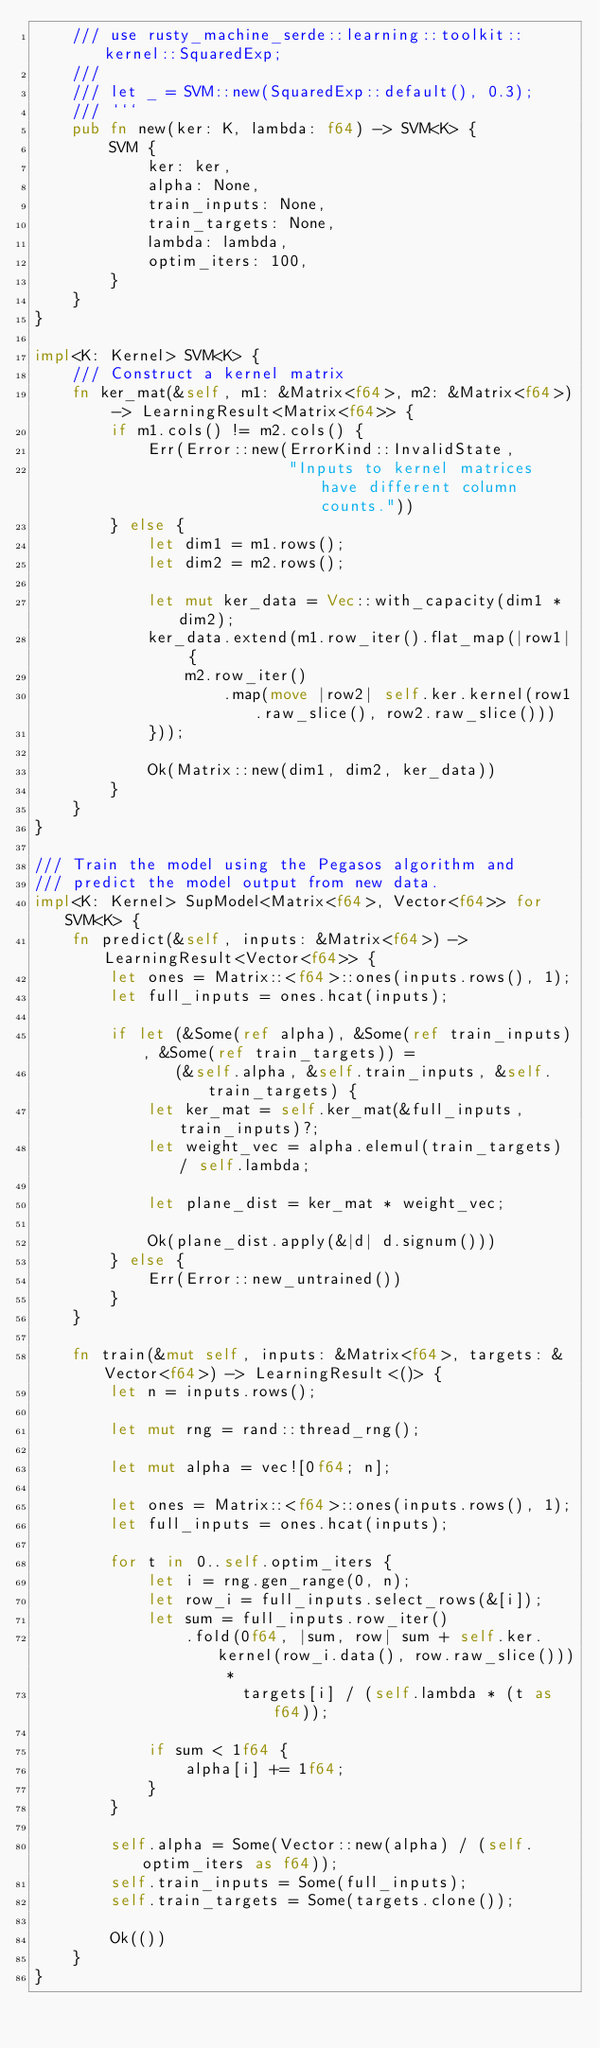<code> <loc_0><loc_0><loc_500><loc_500><_Rust_>    /// use rusty_machine_serde::learning::toolkit::kernel::SquaredExp;
    ///
    /// let _ = SVM::new(SquaredExp::default(), 0.3);
    /// ```
    pub fn new(ker: K, lambda: f64) -> SVM<K> {
        SVM {
            ker: ker,
            alpha: None,
            train_inputs: None,
            train_targets: None,
            lambda: lambda,
            optim_iters: 100,
        }
    }
}

impl<K: Kernel> SVM<K> {
    /// Construct a kernel matrix
    fn ker_mat(&self, m1: &Matrix<f64>, m2: &Matrix<f64>) -> LearningResult<Matrix<f64>> {
        if m1.cols() != m2.cols() {
            Err(Error::new(ErrorKind::InvalidState,
                           "Inputs to kernel matrices have different column counts."))
        } else {
            let dim1 = m1.rows();
            let dim2 = m2.rows();

            let mut ker_data = Vec::with_capacity(dim1 * dim2);
            ker_data.extend(m1.row_iter().flat_map(|row1| {
                m2.row_iter()
                    .map(move |row2| self.ker.kernel(row1.raw_slice(), row2.raw_slice()))
            }));

            Ok(Matrix::new(dim1, dim2, ker_data))
        }
    }
}

/// Train the model using the Pegasos algorithm and
/// predict the model output from new data.
impl<K: Kernel> SupModel<Matrix<f64>, Vector<f64>> for SVM<K> {
    fn predict(&self, inputs: &Matrix<f64>) -> LearningResult<Vector<f64>> {
        let ones = Matrix::<f64>::ones(inputs.rows(), 1);
        let full_inputs = ones.hcat(inputs);

        if let (&Some(ref alpha), &Some(ref train_inputs), &Some(ref train_targets)) =
               (&self.alpha, &self.train_inputs, &self.train_targets) {
            let ker_mat = self.ker_mat(&full_inputs, train_inputs)?;
            let weight_vec = alpha.elemul(train_targets) / self.lambda;

            let plane_dist = ker_mat * weight_vec;

            Ok(plane_dist.apply(&|d| d.signum()))
        } else {
            Err(Error::new_untrained())
        }
    }

    fn train(&mut self, inputs: &Matrix<f64>, targets: &Vector<f64>) -> LearningResult<()> {
        let n = inputs.rows();

        let mut rng = rand::thread_rng();

        let mut alpha = vec![0f64; n];

        let ones = Matrix::<f64>::ones(inputs.rows(), 1);
        let full_inputs = ones.hcat(inputs);

        for t in 0..self.optim_iters {
            let i = rng.gen_range(0, n);
            let row_i = full_inputs.select_rows(&[i]);
            let sum = full_inputs.row_iter()
                .fold(0f64, |sum, row| sum + self.ker.kernel(row_i.data(), row.raw_slice())) *
                      targets[i] / (self.lambda * (t as f64));

            if sum < 1f64 {
                alpha[i] += 1f64;
            }
        }

        self.alpha = Some(Vector::new(alpha) / (self.optim_iters as f64));
        self.train_inputs = Some(full_inputs);
        self.train_targets = Some(targets.clone());

        Ok(())
    }
}
</code> 